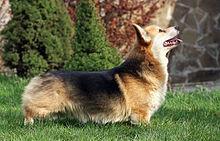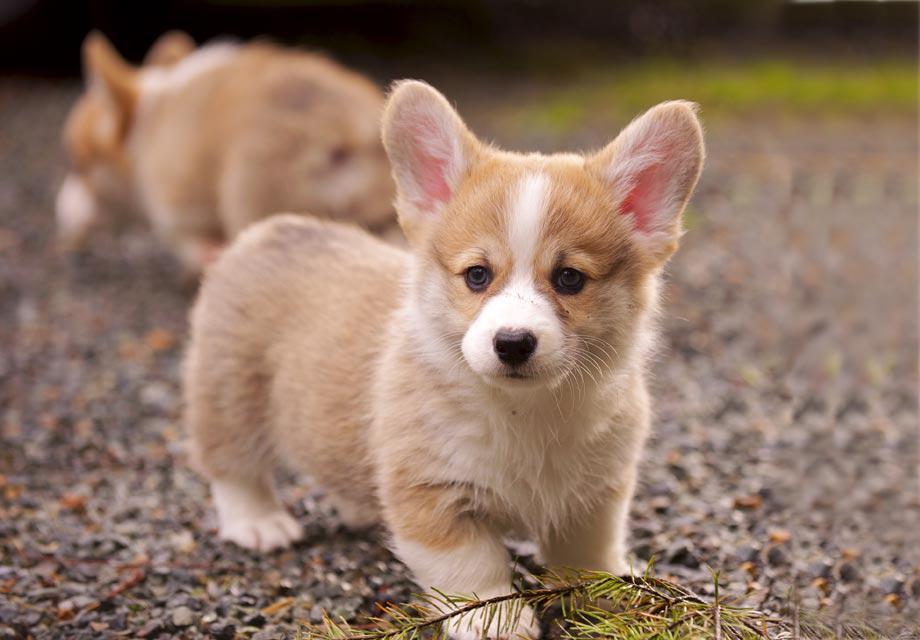The first image is the image on the left, the second image is the image on the right. For the images shown, is this caption "All dogs are looking in the general direction of the camera." true? Answer yes or no. No. The first image is the image on the left, the second image is the image on the right. For the images displayed, is the sentence "The image on the right has a one dog with its tongue showing." factually correct? Answer yes or no. No. 